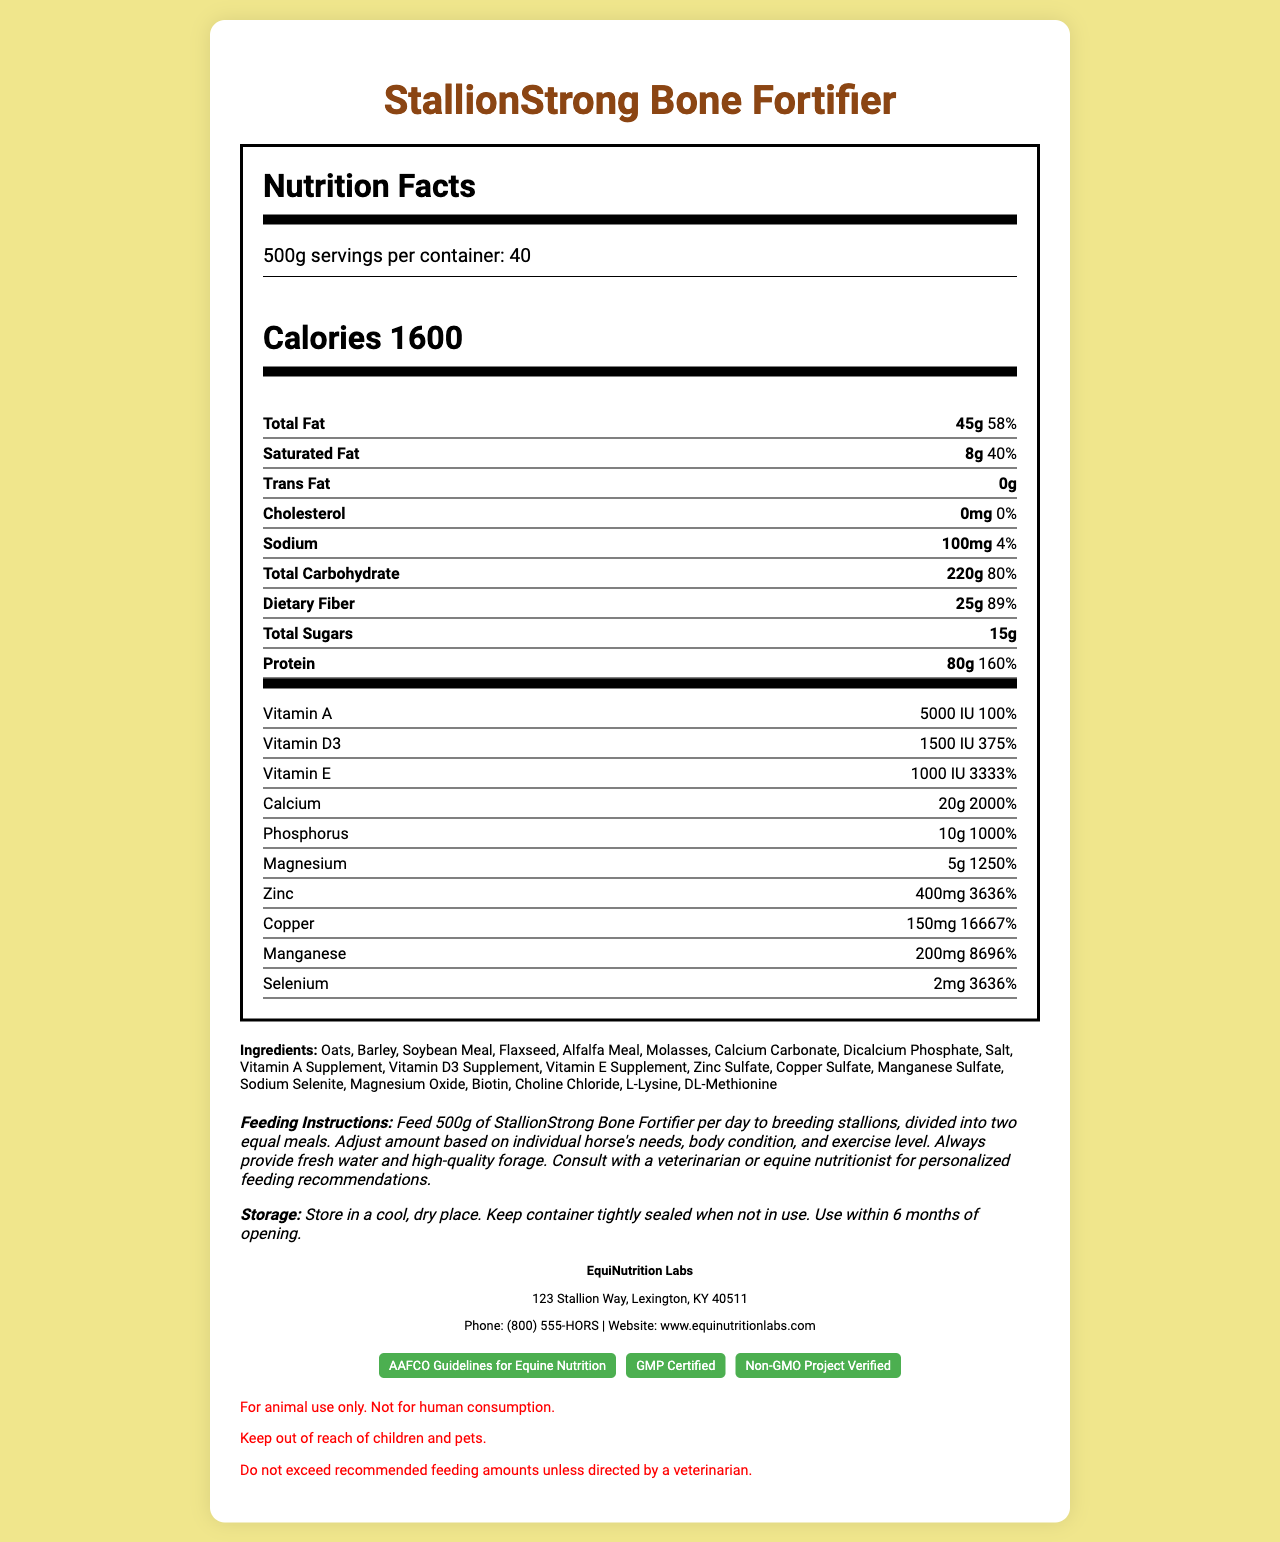what is the serving size? The serving size is listed at the top of the Nutrition Facts under "Serving Size."
Answer: 500g how many servings are in one container? The number of servings per container is mentioned right after the serving size at the top of the Nutrition Facts.
Answer: 40 how many calories are there per serving? The calories per serving are prominently displayed in a large font under the serving information in the Nutrition Facts section.
Answer: 1600 what is the daily value percentage for total fat? The daily value percentage for total fat is written next to the amount of total fat (45g) in the nutrient section.
Answer: 58% which nutrient has the highest daily value percentage? Copper (150mg) has the highest daily value percentage, which is 16667%, as listed in the vitamins and minerals section.
Answer: Copper which of these ingredients is not in the product? A. Barley B. Corn C. Flaxseed D. Soybean Meal Corn is not listed among the ingredients; the listed ingredients include Barley, Flaxseed, and Soybean Meal.
Answer: B. Corn what is the feeding instruction for StallionStrong Bone Fortifier? The feeding instruction is provided in a paragraph format under the heading "Feeding Instructions."
Answer: Feed 500g of StallionStrong Bone Fortifier per day to breeding stallions, divided into two equal meals. Adjust the amount based on individual horse's needs, body condition, and exercise level. Always provide fresh water and high-quality forage. Consult with a veterinarian or equine nutritionist for personalized feeding recommendations. how much protein is in one serving? The amount of protein per serving is listed as 80g in the nutrient section.
Answer: 80g which vitamins are included in this product? The product contains Vitamin A (5000 IU), Vitamin D3 (1500 IU), and Vitamin E (1000 IU), as listed in the vitamins and minerals section.
Answer: Vitamin A, Vitamin D3, Vitamin E is this product suitable for human consumption? The warnings section clearly states "For animal use only. Not for human consumption."
Answer: No which mineral contributes the most to bone strength? A. Calcium B. Iron C. Manganese D. Zinc Calcium contributes 20g with a daily value of 2000%, indicating its significant role in bone strength.
Answer: A. Calcium how should the product be stored? The storage instructions are clearly outlined under the "Storage Instructions" in the document.
Answer: Store in a cool, dry place. Keep the container tightly sealed when not in use. Use within 6 months of opening. which organization’s guidelines does this product follow? The product is certified to follow the "AAFCO Guidelines for Equine Nutrition," as noted in the certifications section.
Answer: AAFCO Guidelines for Equine Nutrition who is the manufacturer of StallionStrong Bone Fortifier? The manufacturer's name and details are provided under the manufacturer info section.
Answer: EquiNutrition Labs does the product include any non-GMO verified certification? The product is listed as "Non-GMO Project Verified" in the certification badges section.
Answer: Yes what is the exact address of EquiNutrition Labs? The address is given in the manufacturer info section.
Answer: 123 Stallion Way, Lexington, KY 40511 what is the main purpose of the document? The document details aspects such as nutritional content, feeding instructions, ingredients, storage, and manufacturer information.
Answer: To provide comprehensive nutritional and product information about the StallionStrong Bone Fortifier feed concentrate for breeding stallions. what is the price of this product? The document does not provide any information on the price of the product.
Answer: Not enough information 